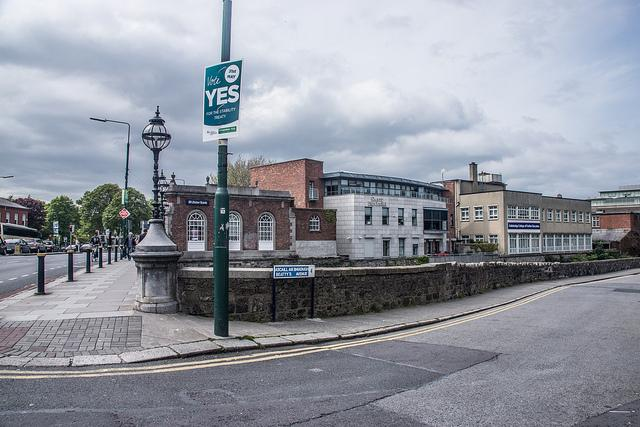The clouds here indicate what might happen?

Choices:
A) tornado
B) wind tunnel
C) rain
D) sunny skies rain 